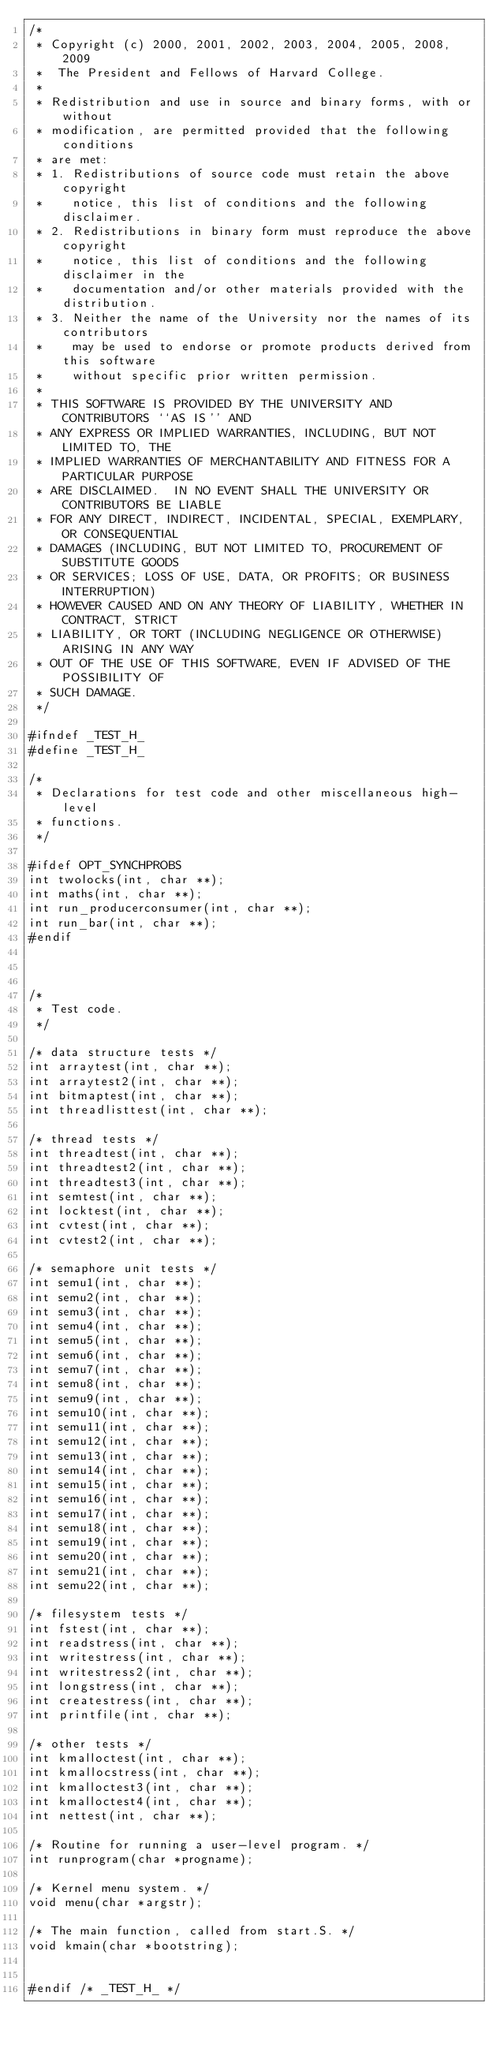Convert code to text. <code><loc_0><loc_0><loc_500><loc_500><_C_>/*
 * Copyright (c) 2000, 2001, 2002, 2003, 2004, 2005, 2008, 2009
 *	The President and Fellows of Harvard College.
 *
 * Redistribution and use in source and binary forms, with or without
 * modification, are permitted provided that the following conditions
 * are met:
 * 1. Redistributions of source code must retain the above copyright
 *    notice, this list of conditions and the following disclaimer.
 * 2. Redistributions in binary form must reproduce the above copyright
 *    notice, this list of conditions and the following disclaimer in the
 *    documentation and/or other materials provided with the distribution.
 * 3. Neither the name of the University nor the names of its contributors
 *    may be used to endorse or promote products derived from this software
 *    without specific prior written permission.
 *
 * THIS SOFTWARE IS PROVIDED BY THE UNIVERSITY AND CONTRIBUTORS ``AS IS'' AND
 * ANY EXPRESS OR IMPLIED WARRANTIES, INCLUDING, BUT NOT LIMITED TO, THE
 * IMPLIED WARRANTIES OF MERCHANTABILITY AND FITNESS FOR A PARTICULAR PURPOSE
 * ARE DISCLAIMED.  IN NO EVENT SHALL THE UNIVERSITY OR CONTRIBUTORS BE LIABLE
 * FOR ANY DIRECT, INDIRECT, INCIDENTAL, SPECIAL, EXEMPLARY, OR CONSEQUENTIAL
 * DAMAGES (INCLUDING, BUT NOT LIMITED TO, PROCUREMENT OF SUBSTITUTE GOODS
 * OR SERVICES; LOSS OF USE, DATA, OR PROFITS; OR BUSINESS INTERRUPTION)
 * HOWEVER CAUSED AND ON ANY THEORY OF LIABILITY, WHETHER IN CONTRACT, STRICT
 * LIABILITY, OR TORT (INCLUDING NEGLIGENCE OR OTHERWISE) ARISING IN ANY WAY
 * OUT OF THE USE OF THIS SOFTWARE, EVEN IF ADVISED OF THE POSSIBILITY OF
 * SUCH DAMAGE.
 */

#ifndef _TEST_H_
#define _TEST_H_

/*
 * Declarations for test code and other miscellaneous high-level
 * functions.
 */

#ifdef OPT_SYNCHPROBS
int twolocks(int, char **);
int maths(int, char **);
int run_producerconsumer(int, char **);
int run_bar(int, char **);
#endif



/*
 * Test code.
 */

/* data structure tests */
int arraytest(int, char **);
int arraytest2(int, char **);
int bitmaptest(int, char **);
int threadlisttest(int, char **);

/* thread tests */
int threadtest(int, char **);
int threadtest2(int, char **);
int threadtest3(int, char **);
int semtest(int, char **);
int locktest(int, char **);
int cvtest(int, char **);
int cvtest2(int, char **);

/* semaphore unit tests */
int semu1(int, char **);
int semu2(int, char **);
int semu3(int, char **);
int semu4(int, char **);
int semu5(int, char **);
int semu6(int, char **);
int semu7(int, char **);
int semu8(int, char **);
int semu9(int, char **);
int semu10(int, char **);
int semu11(int, char **);
int semu12(int, char **);
int semu13(int, char **);
int semu14(int, char **);
int semu15(int, char **);
int semu16(int, char **);
int semu17(int, char **);
int semu18(int, char **);
int semu19(int, char **);
int semu20(int, char **);
int semu21(int, char **);
int semu22(int, char **);

/* filesystem tests */
int fstest(int, char **);
int readstress(int, char **);
int writestress(int, char **);
int writestress2(int, char **);
int longstress(int, char **);
int createstress(int, char **);
int printfile(int, char **);

/* other tests */
int kmalloctest(int, char **);
int kmallocstress(int, char **);
int kmalloctest3(int, char **);
int kmalloctest4(int, char **);
int nettest(int, char **);

/* Routine for running a user-level program. */
int runprogram(char *progname);

/* Kernel menu system. */
void menu(char *argstr);

/* The main function, called from start.S. */
void kmain(char *bootstring);


#endif /* _TEST_H_ */
</code> 